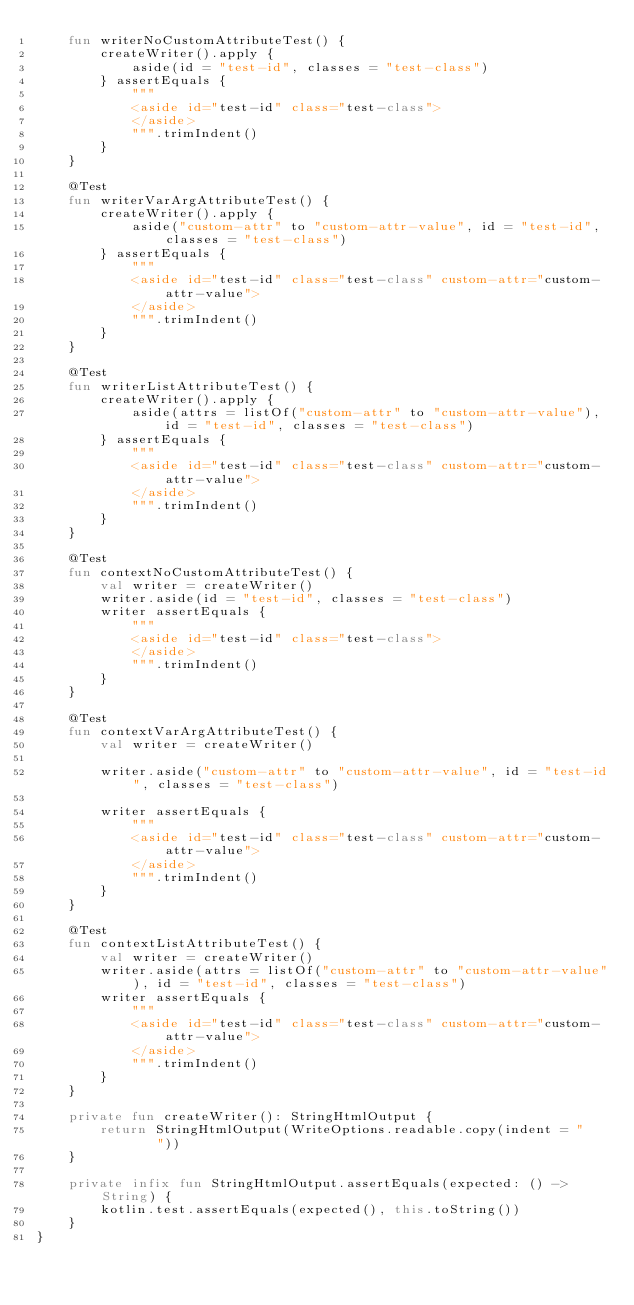<code> <loc_0><loc_0><loc_500><loc_500><_Kotlin_>    fun writerNoCustomAttributeTest() {
        createWriter().apply {
            aside(id = "test-id", classes = "test-class")
        } assertEquals {
            """
            <aside id="test-id" class="test-class">
            </aside>
            """.trimIndent()
        }
    }

    @Test
    fun writerVarArgAttributeTest() {
        createWriter().apply {
            aside("custom-attr" to "custom-attr-value", id = "test-id", classes = "test-class")
        } assertEquals {
            """
            <aside id="test-id" class="test-class" custom-attr="custom-attr-value">
            </aside>
            """.trimIndent()
        }
    }

    @Test
    fun writerListAttributeTest() {
        createWriter().apply {
            aside(attrs = listOf("custom-attr" to "custom-attr-value"), id = "test-id", classes = "test-class")
        } assertEquals {
            """
            <aside id="test-id" class="test-class" custom-attr="custom-attr-value">
            </aside>
            """.trimIndent()
        }
    }

    @Test
    fun contextNoCustomAttributeTest() {
        val writer = createWriter()
        writer.aside(id = "test-id", classes = "test-class")
        writer assertEquals {
            """
            <aside id="test-id" class="test-class">
            </aside>
            """.trimIndent()
        }
    }

    @Test
    fun contextVarArgAttributeTest() {
        val writer = createWriter()

        writer.aside("custom-attr" to "custom-attr-value", id = "test-id", classes = "test-class")

        writer assertEquals {
            """
            <aside id="test-id" class="test-class" custom-attr="custom-attr-value">
            </aside>
            """.trimIndent()
        }
    }

    @Test
    fun contextListAttributeTest() {
        val writer = createWriter()
        writer.aside(attrs = listOf("custom-attr" to "custom-attr-value"), id = "test-id", classes = "test-class")
        writer assertEquals {
            """
            <aside id="test-id" class="test-class" custom-attr="custom-attr-value">
            </aside>
            """.trimIndent()
        }
    }

    private fun createWriter(): StringHtmlOutput {
        return StringHtmlOutput(WriteOptions.readable.copy(indent = "    "))
    }

    private infix fun StringHtmlOutput.assertEquals(expected: () -> String) {
        kotlin.test.assertEquals(expected(), this.toString())
    }
}
</code> 